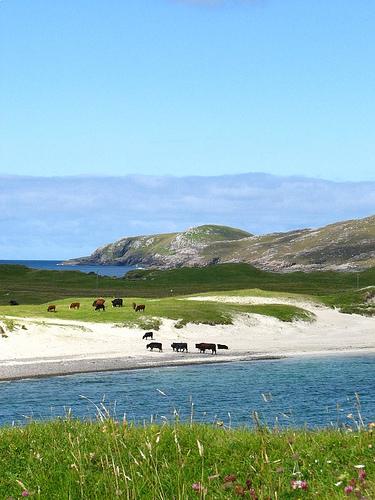What percentage of the picture is water?
Give a very brief answer. 20%. What animals are walking along the bank?
Short answer required. Cows. Is there an ocean in this picture?
Keep it brief. Yes. How many farm animals can be seen?
Concise answer only. 11. 